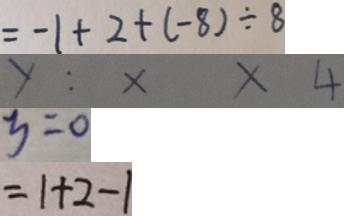<formula> <loc_0><loc_0><loc_500><loc_500>= - 1 + 2 + ( - 8 ) \div 8 
 y : x x 4 
 y = 0 
 = 1 + 2 - 1</formula> 